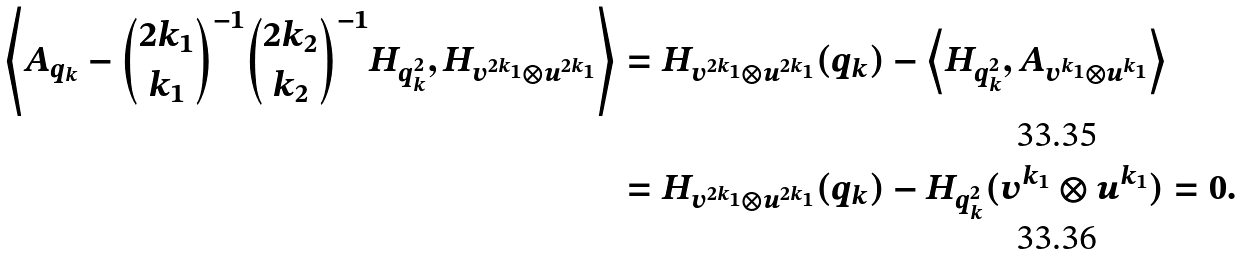<formula> <loc_0><loc_0><loc_500><loc_500>\left \langle A _ { q _ { k } } - \binom { 2 k _ { 1 } } { k _ { 1 } } ^ { - 1 } \binom { 2 k _ { 2 } } { k _ { 2 } } ^ { - 1 } H _ { q _ { k } ^ { 2 } } , H _ { v ^ { 2 k _ { 1 } } \otimes u ^ { 2 k _ { 1 } } } \right \rangle & = H _ { v ^ { 2 k _ { 1 } } \otimes u ^ { 2 k _ { 1 } } } ( q _ { k } ) - \left \langle H _ { q _ { k } ^ { 2 } } , A _ { v ^ { k _ { 1 } } \otimes u ^ { k _ { 1 } } } \right \rangle \\ & = H _ { v ^ { 2 k _ { 1 } } \otimes u ^ { 2 k _ { 1 } } } ( q _ { k } ) - H _ { q _ { k } ^ { 2 } } ( v ^ { k _ { 1 } } \otimes u ^ { k _ { 1 } } ) = 0 .</formula> 